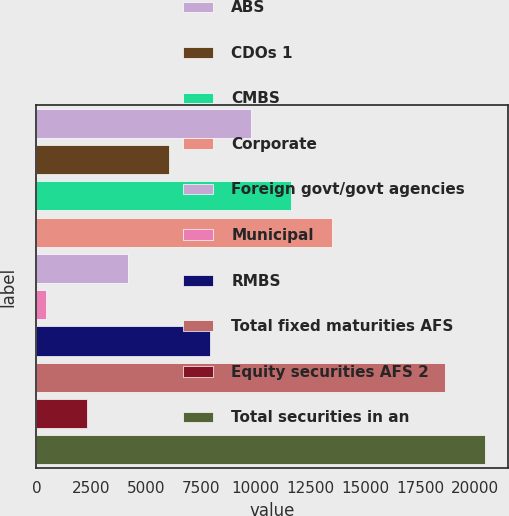Convert chart. <chart><loc_0><loc_0><loc_500><loc_500><bar_chart><fcel>ABS<fcel>CDOs 1<fcel>CMBS<fcel>Corporate<fcel>Foreign govt/govt agencies<fcel>Municipal<fcel>RMBS<fcel>Total fixed maturities AFS<fcel>Equity securities AFS 2<fcel>Total securities in an<nl><fcel>9767.5<fcel>6036.5<fcel>11633<fcel>13498.5<fcel>4171<fcel>440<fcel>7902<fcel>18615<fcel>2305.5<fcel>20480.5<nl></chart> 